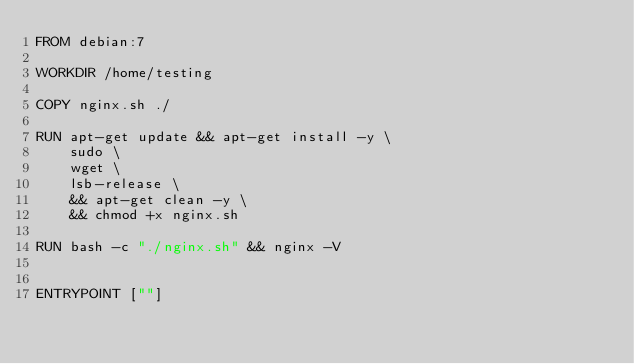Convert code to text. <code><loc_0><loc_0><loc_500><loc_500><_Dockerfile_>FROM debian:7

WORKDIR /home/testing

COPY nginx.sh ./

RUN apt-get update && apt-get install -y \
    sudo \
    wget \
    lsb-release \
    && apt-get clean -y \
    && chmod +x nginx.sh

RUN bash -c "./nginx.sh" && nginx -V


ENTRYPOINT [""]

</code> 